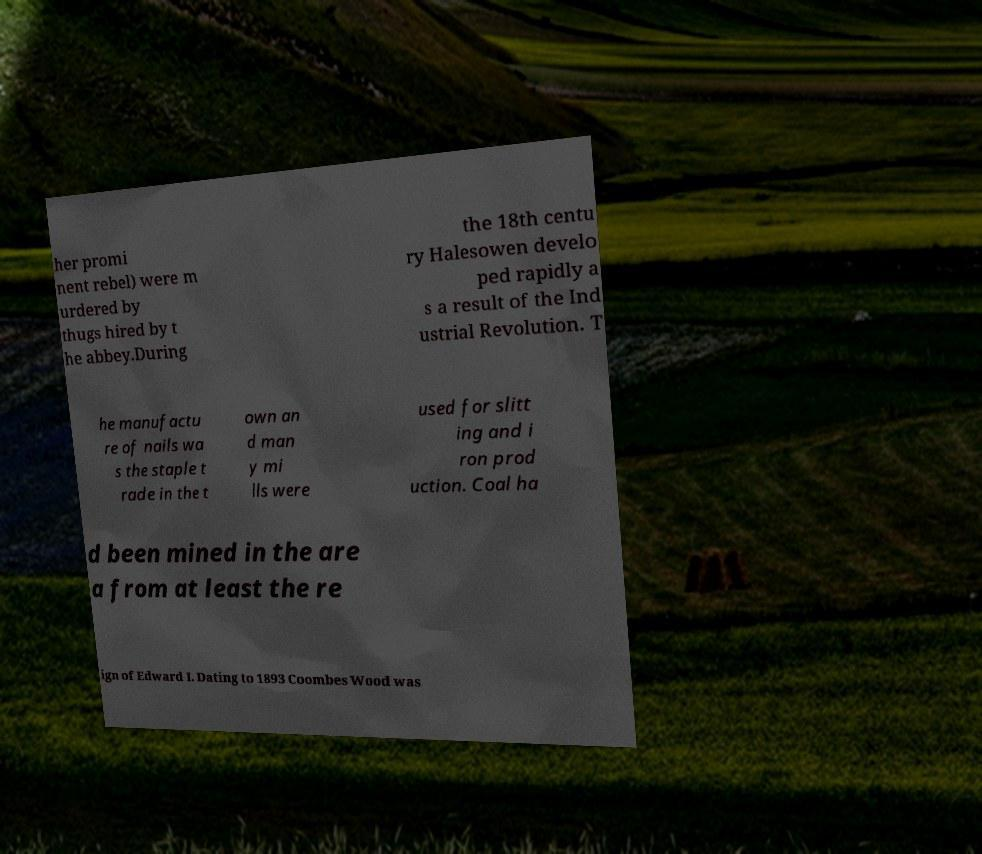I need the written content from this picture converted into text. Can you do that? her promi nent rebel) were m urdered by thugs hired by t he abbey.During the 18th centu ry Halesowen develo ped rapidly a s a result of the Ind ustrial Revolution. T he manufactu re of nails wa s the staple t rade in the t own an d man y mi lls were used for slitt ing and i ron prod uction. Coal ha d been mined in the are a from at least the re ign of Edward I. Dating to 1893 Coombes Wood was 